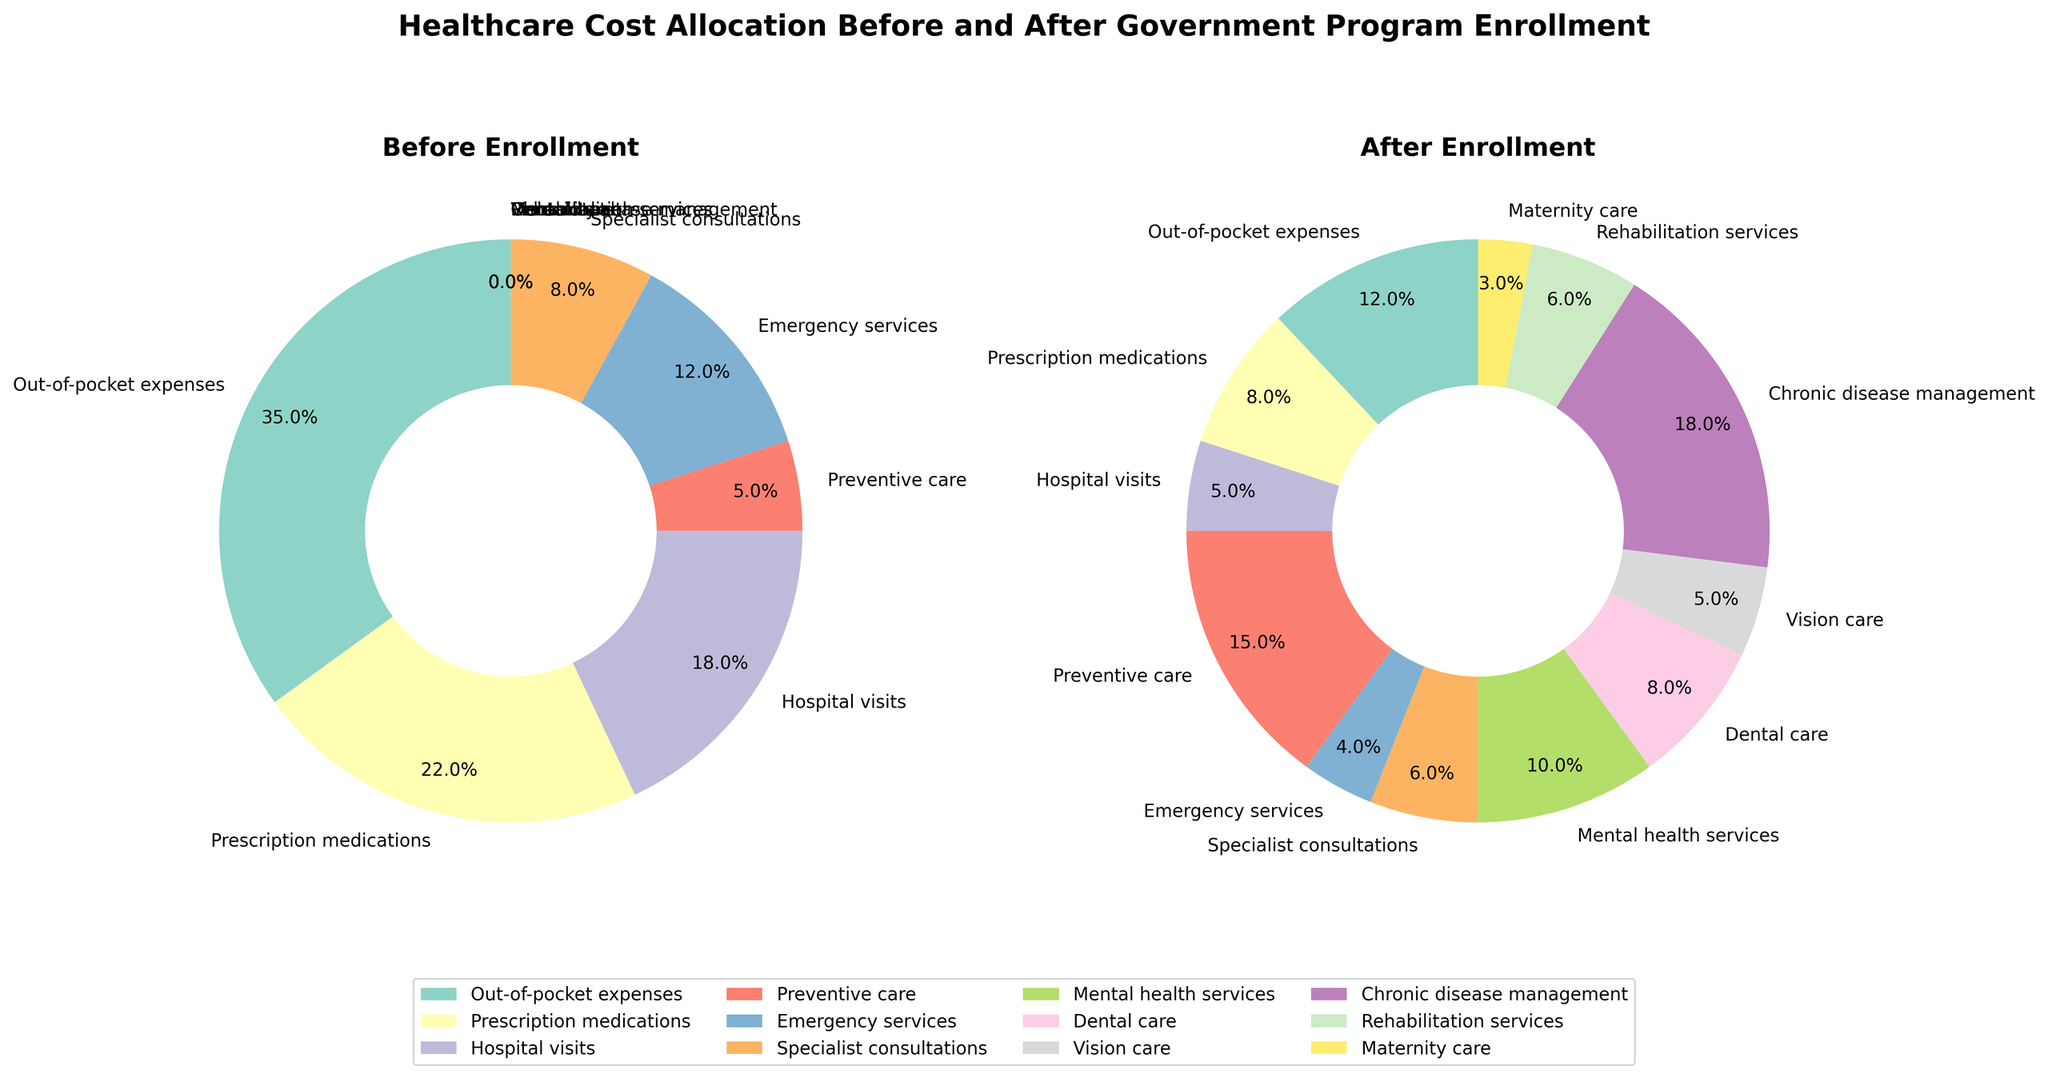what is the title of the figure? The title of the figure is available at the top and reads: 'Healthcare Cost Allocation Before and After Government Program Enrollment'.
Answer: 'Healthcare Cost Allocation Before and After Government Program Enrollment' How many categories have allocations of 0% before enrollment? Before enrollment, categories with 0% allocations are Mental health services, Dental care, Vision care, Chronic disease management, Rehabilitation services, and Maternity care. There are a total of 6 such categories.
Answer: 6 What percentage of healthcare costs is attributed to chronic disease management after enrollment? Chronic disease management accounts for 18% of healthcare costs after enrollment, which can be seen from the 'After Enrollment' pie chart.
Answer: 18% Which category sees the largest decrease in percentage allocation after enrollment? Out-of-pocket expenses show the largest decrease from 35% before enrollment to 12% after enrollment, hence a decrease of 23%.
Answer: Out-of-pocket expenses What is the combined percentage of mental health services, dental care, and vision care after enrollment? Adding the percentages for mental health services (10%), dental care (8%), and vision care (5%) after enrollment gives a combined percentage of 23%.
Answer: 23% How does the percentage allocation for preventive care change after enrollment? Preventive care goes from 5% before enrollment to 15% after enrollment, showing an increase of 10 percentage points.
Answer: Increases by 10 percentage points Compare the percentage allocations for prescription medications before and after enrollment. Prescription medications have a percentage allocation of 22% before enrollment and 8% after enrollment. Therefore, it decreases by 14 percentage points.
Answer: Decreases by 14 percentage points What is the total percentage allocation for hospital visits and emergency services before enrollment? Adding up the percentages for hospital visits (18%) and emergency services (12%) before enrollment gives a total allocation of 30%.
Answer: 30% Identify which new categories are introduced after enrollment and their respective percentages. After enrollment, the new categories introduced are Mental health services (10%), Dental care (8%), Vision care (5%), Chronic disease management (18%), Rehabilitation services (6%), and Maternity care (3%) as depicted in the 'After Enrollment' pie chart.
Answer: Mental health services (10%), Dental care (8%), Vision care (5%), Chronic disease management (18%), Rehabilitation services (6%), Maternity care (3%) 